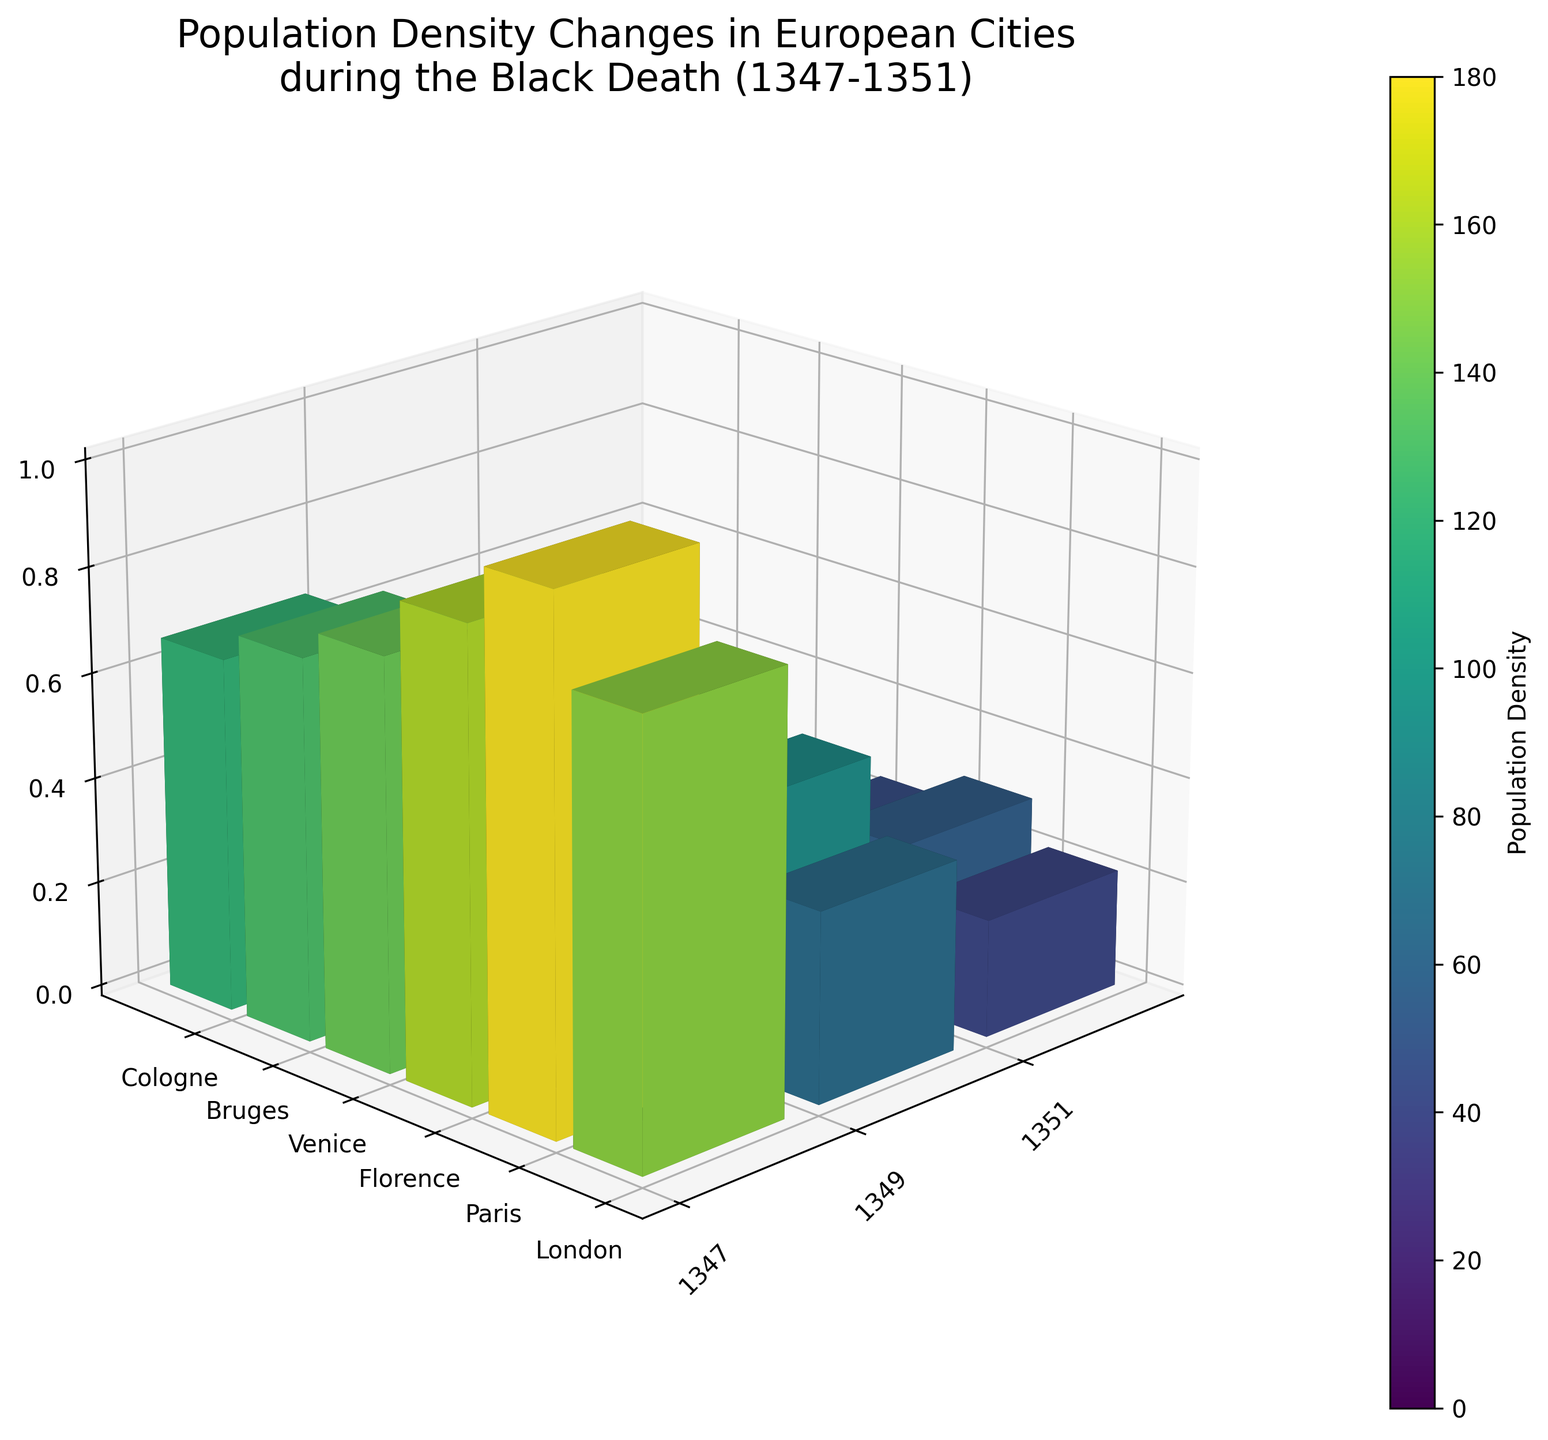How many cities are represented in the plot? Count the number of different city labels on the y-axis. There are six labels: London, Paris, Florence, Venice, Bruges, and Cologne.
Answer: Six Which city had the highest population density in 1347? Look at the heights of the bars for the year 1347 on the x-axis and identify which one is the tallest. London is the highest.
Answer: London What is the title of the figure? Read the text at the top of the plot that describes the purpose or content of the plot. The title is "Population Density Changes in European Cities during the Black Death (1347-1351)."
Answer: Population Density Changes in European Cities during the Black Death (1347-1351) How did the population density of Venice change from 1349 to 1351? Compare the heights of the bars for Venice at 1349 and 1351. The bar height decreased from 75 (1349) to 50 (1351).
Answer: Decreased from 75 to 50 Which city experienced the largest percentage decrease in population density from 1347 to 1351? For each city, calculate the percentage decrease from 1347 to 1351 [(Population_Density_1347 - Population_Density_1351) / Population_Density_1347 * 100]. The city with the largest result is Bruges.
Answer: Bruges What's the overall trend in population density changes across European cities from 1347 to 1351? Observe the general direction of the bars for consecutive years. The bars decrease in height consistently over time for all cities, indicating a decreasing trend in population density.
Answer: Decreasing Which city had the lowest population density in 1351? Look at the heights of the bars for the year 1351 on the x-axis and identify which one is the shortest. Cologne is the shortest.
Answer: Cologne What color represents the lowest population density in the plot? Look at the color scale (color bar) provided, which will indicate the colors corresponding to different density values. The lowest densities are shown in dark blue colors.
Answer: Dark blue How does the population density of Florence in 1347 compare to Paris in 1349? Compare the heights and colors of the bars for Florence in 1347 and Paris in 1349. Florence in 1347 has a density of 160, which is higher than Paris in 1349 with a density of 90.
Answer: Florence is higher By how much did the population density of Cologne decrease from 1347 to 1349? Subtract the population density of Cologne in 1349 from that in 1347 (120 - 55).
Answer: 65 